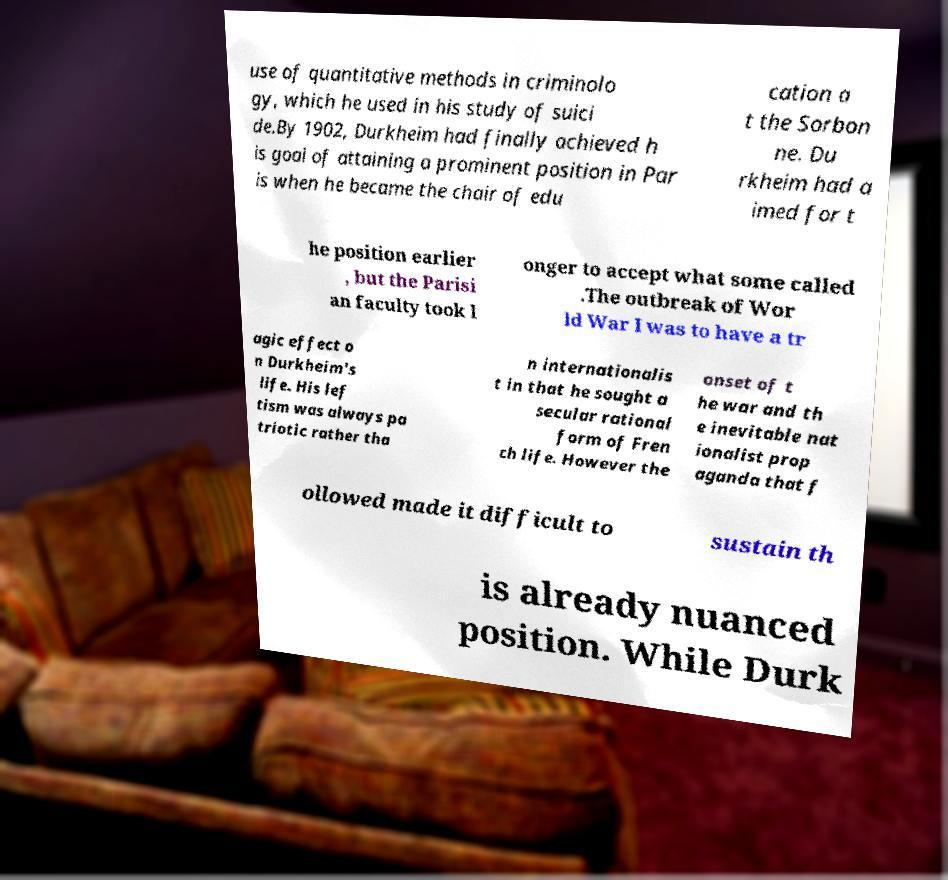For documentation purposes, I need the text within this image transcribed. Could you provide that? use of quantitative methods in criminolo gy, which he used in his study of suici de.By 1902, Durkheim had finally achieved h is goal of attaining a prominent position in Par is when he became the chair of edu cation a t the Sorbon ne. Du rkheim had a imed for t he position earlier , but the Parisi an faculty took l onger to accept what some called .The outbreak of Wor ld War I was to have a tr agic effect o n Durkheim's life. His lef tism was always pa triotic rather tha n internationalis t in that he sought a secular rational form of Fren ch life. However the onset of t he war and th e inevitable nat ionalist prop aganda that f ollowed made it difficult to sustain th is already nuanced position. While Durk 